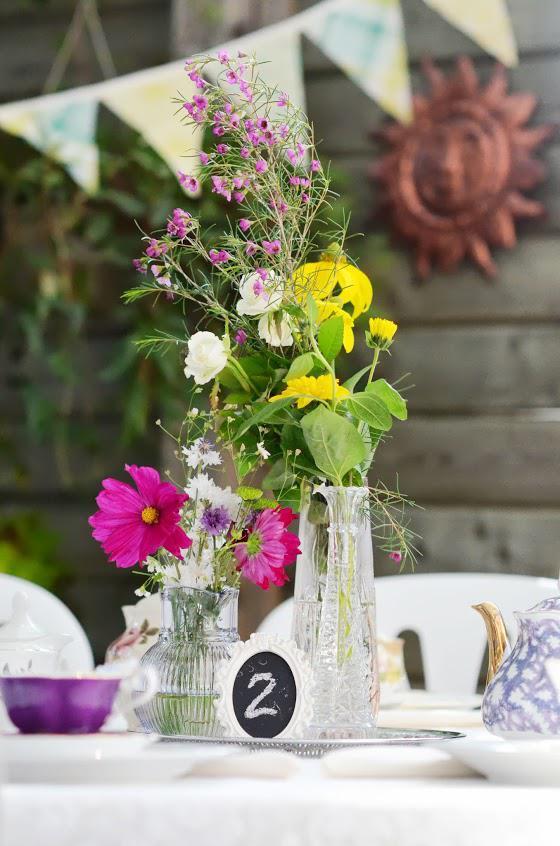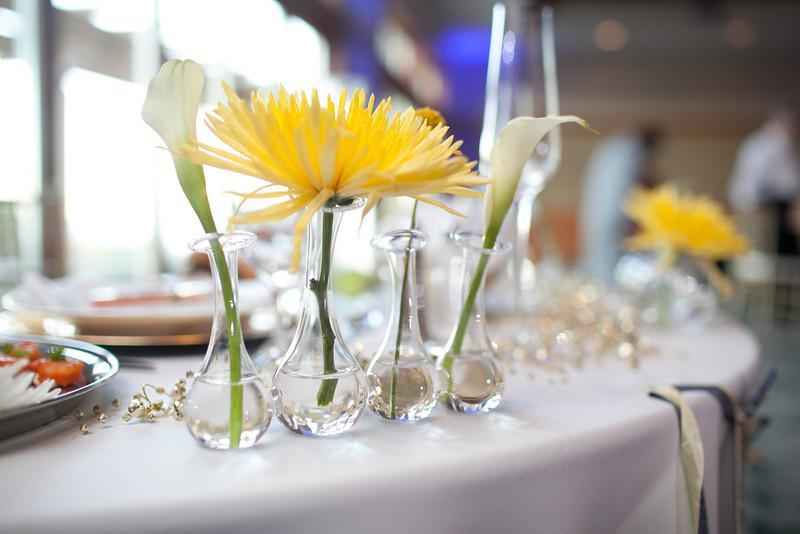The first image is the image on the left, the second image is the image on the right. Examine the images to the left and right. Is the description "Right image features a variety of flowers, including roses." accurate? Answer yes or no. No. The first image is the image on the left, the second image is the image on the right. Given the left and right images, does the statement "Purple hyacinth and moss are growing in at least one white planter in the image on the left." hold true? Answer yes or no. No. 